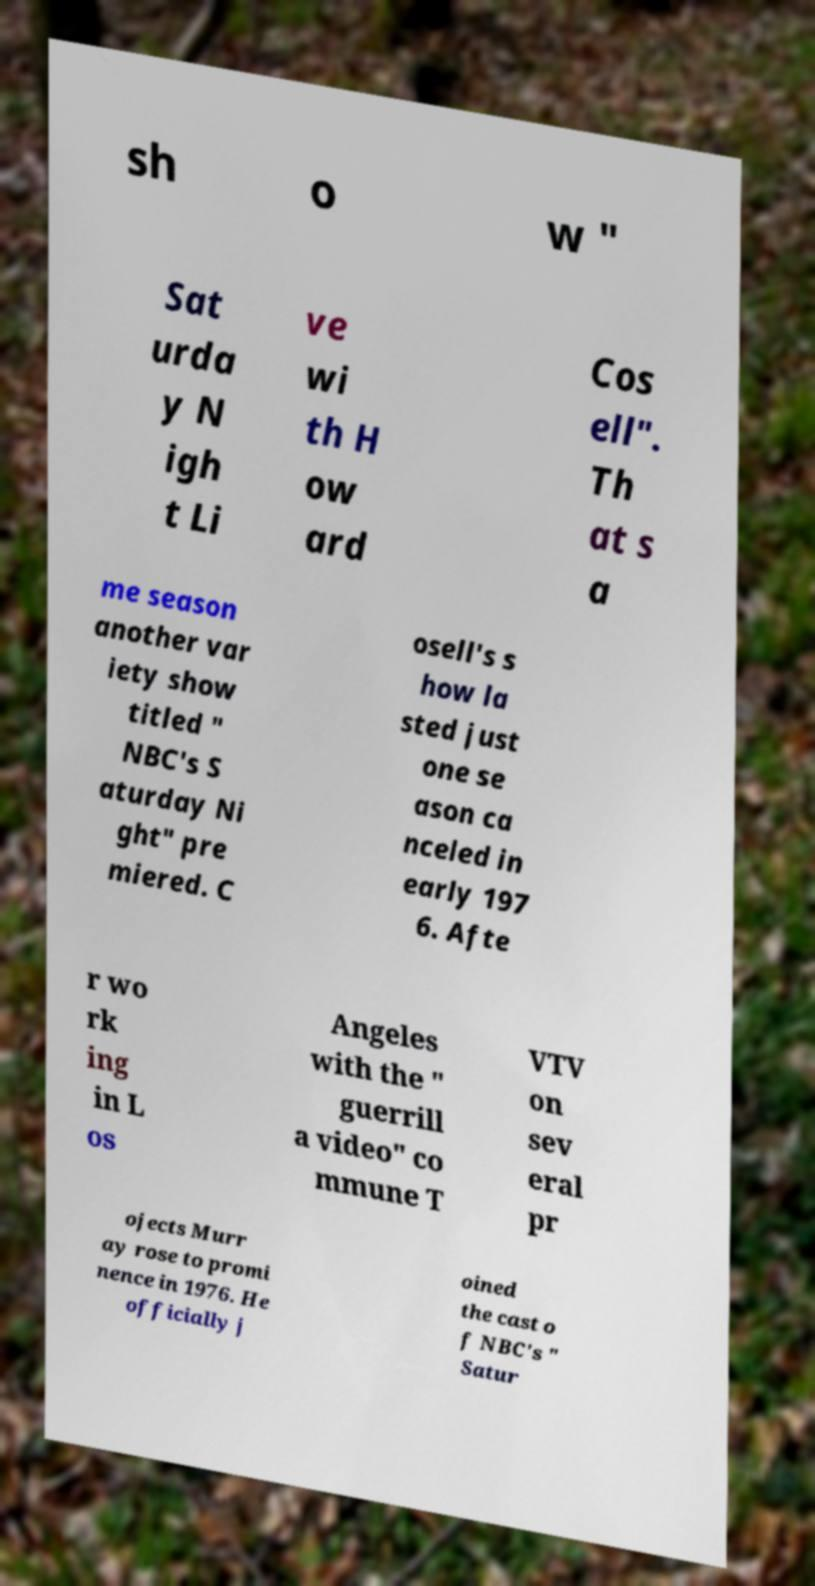I need the written content from this picture converted into text. Can you do that? sh o w " Sat urda y N igh t Li ve wi th H ow ard Cos ell". Th at s a me season another var iety show titled " NBC's S aturday Ni ght" pre miered. C osell's s how la sted just one se ason ca nceled in early 197 6. Afte r wo rk ing in L os Angeles with the " guerrill a video" co mmune T VTV on sev eral pr ojects Murr ay rose to promi nence in 1976. He officially j oined the cast o f NBC's " Satur 